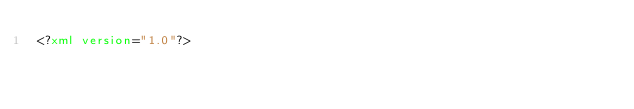Convert code to text. <code><loc_0><loc_0><loc_500><loc_500><_XML_><?xml version="1.0"?></code> 